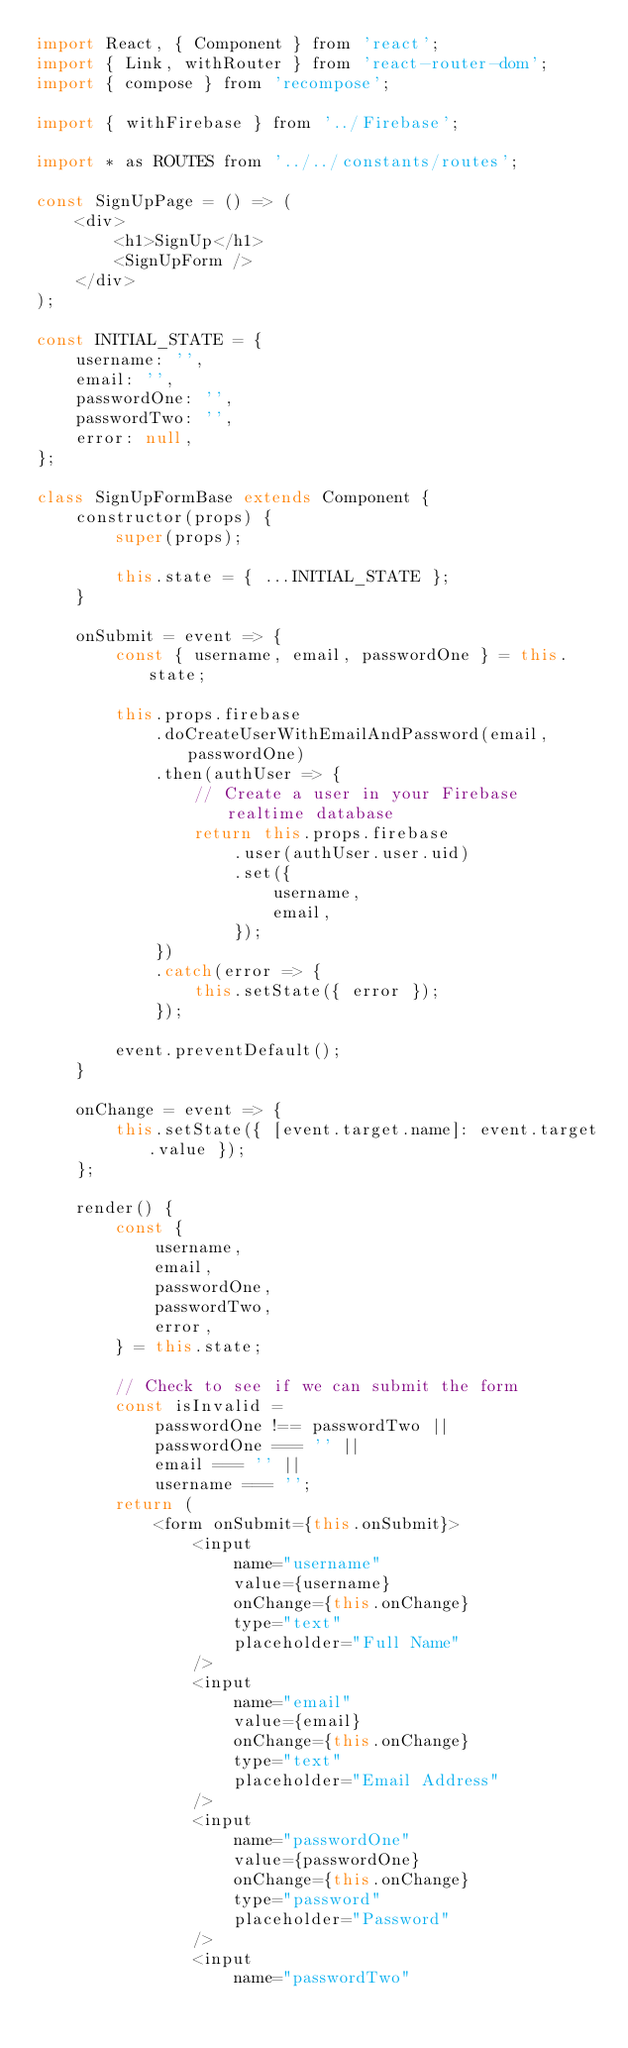<code> <loc_0><loc_0><loc_500><loc_500><_JavaScript_>import React, { Component } from 'react';
import { Link, withRouter } from 'react-router-dom';
import { compose } from 'recompose';

import { withFirebase } from '../Firebase';

import * as ROUTES from '../../constants/routes';

const SignUpPage = () => (
    <div>
        <h1>SignUp</h1>
        <SignUpForm />
    </div>
);

const INITIAL_STATE = {
    username: '',
    email: '',
    passwordOne: '',
    passwordTwo: '',
    error: null,
};

class SignUpFormBase extends Component {
    constructor(props) {
        super(props);

        this.state = { ...INITIAL_STATE };
    }

    onSubmit = event => {
        const { username, email, passwordOne } = this.state;
 
        this.props.firebase
            .doCreateUserWithEmailAndPassword(email, passwordOne)
            .then(authUser => {
                // Create a user in your Firebase realtime database
                return this.props.firebase
                    .user(authUser.user.uid)
                    .set({
                        username,
                        email,
                    });
            })
            .catch(error => {
                this.setState({ error });
            });
    
        event.preventDefault();
    }
    
    onChange = event => {
        this.setState({ [event.target.name]: event.target.value });
    };

    render() {
        const {
            username,
            email,
            passwordOne,
            passwordTwo,
            error,
        } = this.state;

        // Check to see if we can submit the form
        const isInvalid =
            passwordOne !== passwordTwo ||
            passwordOne === '' ||
            email === '' ||
            username === '';
        return (
            <form onSubmit={this.onSubmit}>
                <input
                    name="username"
                    value={username}
                    onChange={this.onChange}
                    type="text"
                    placeholder="Full Name"
                />
                <input
                    name="email"
                    value={email}
                    onChange={this.onChange}
                    type="text"
                    placeholder="Email Address"
                />
                <input
                    name="passwordOne"
                    value={passwordOne}
                    onChange={this.onChange}
                    type="password"
                    placeholder="Password"
                />
                <input
                    name="passwordTwo"</code> 